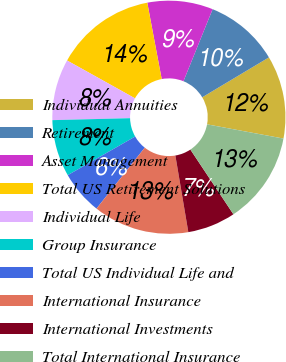<chart> <loc_0><loc_0><loc_500><loc_500><pie_chart><fcel>Individual Annuities<fcel>Retirement<fcel>Asset Management<fcel>Total US Retirement Solutions<fcel>Individual Life<fcel>Group Insurance<fcel>Total US Individual Life and<fcel>International Insurance<fcel>International Investments<fcel>Total International Insurance<nl><fcel>11.51%<fcel>10.3%<fcel>9.09%<fcel>13.94%<fcel>8.49%<fcel>7.88%<fcel>6.06%<fcel>13.33%<fcel>6.67%<fcel>12.73%<nl></chart> 